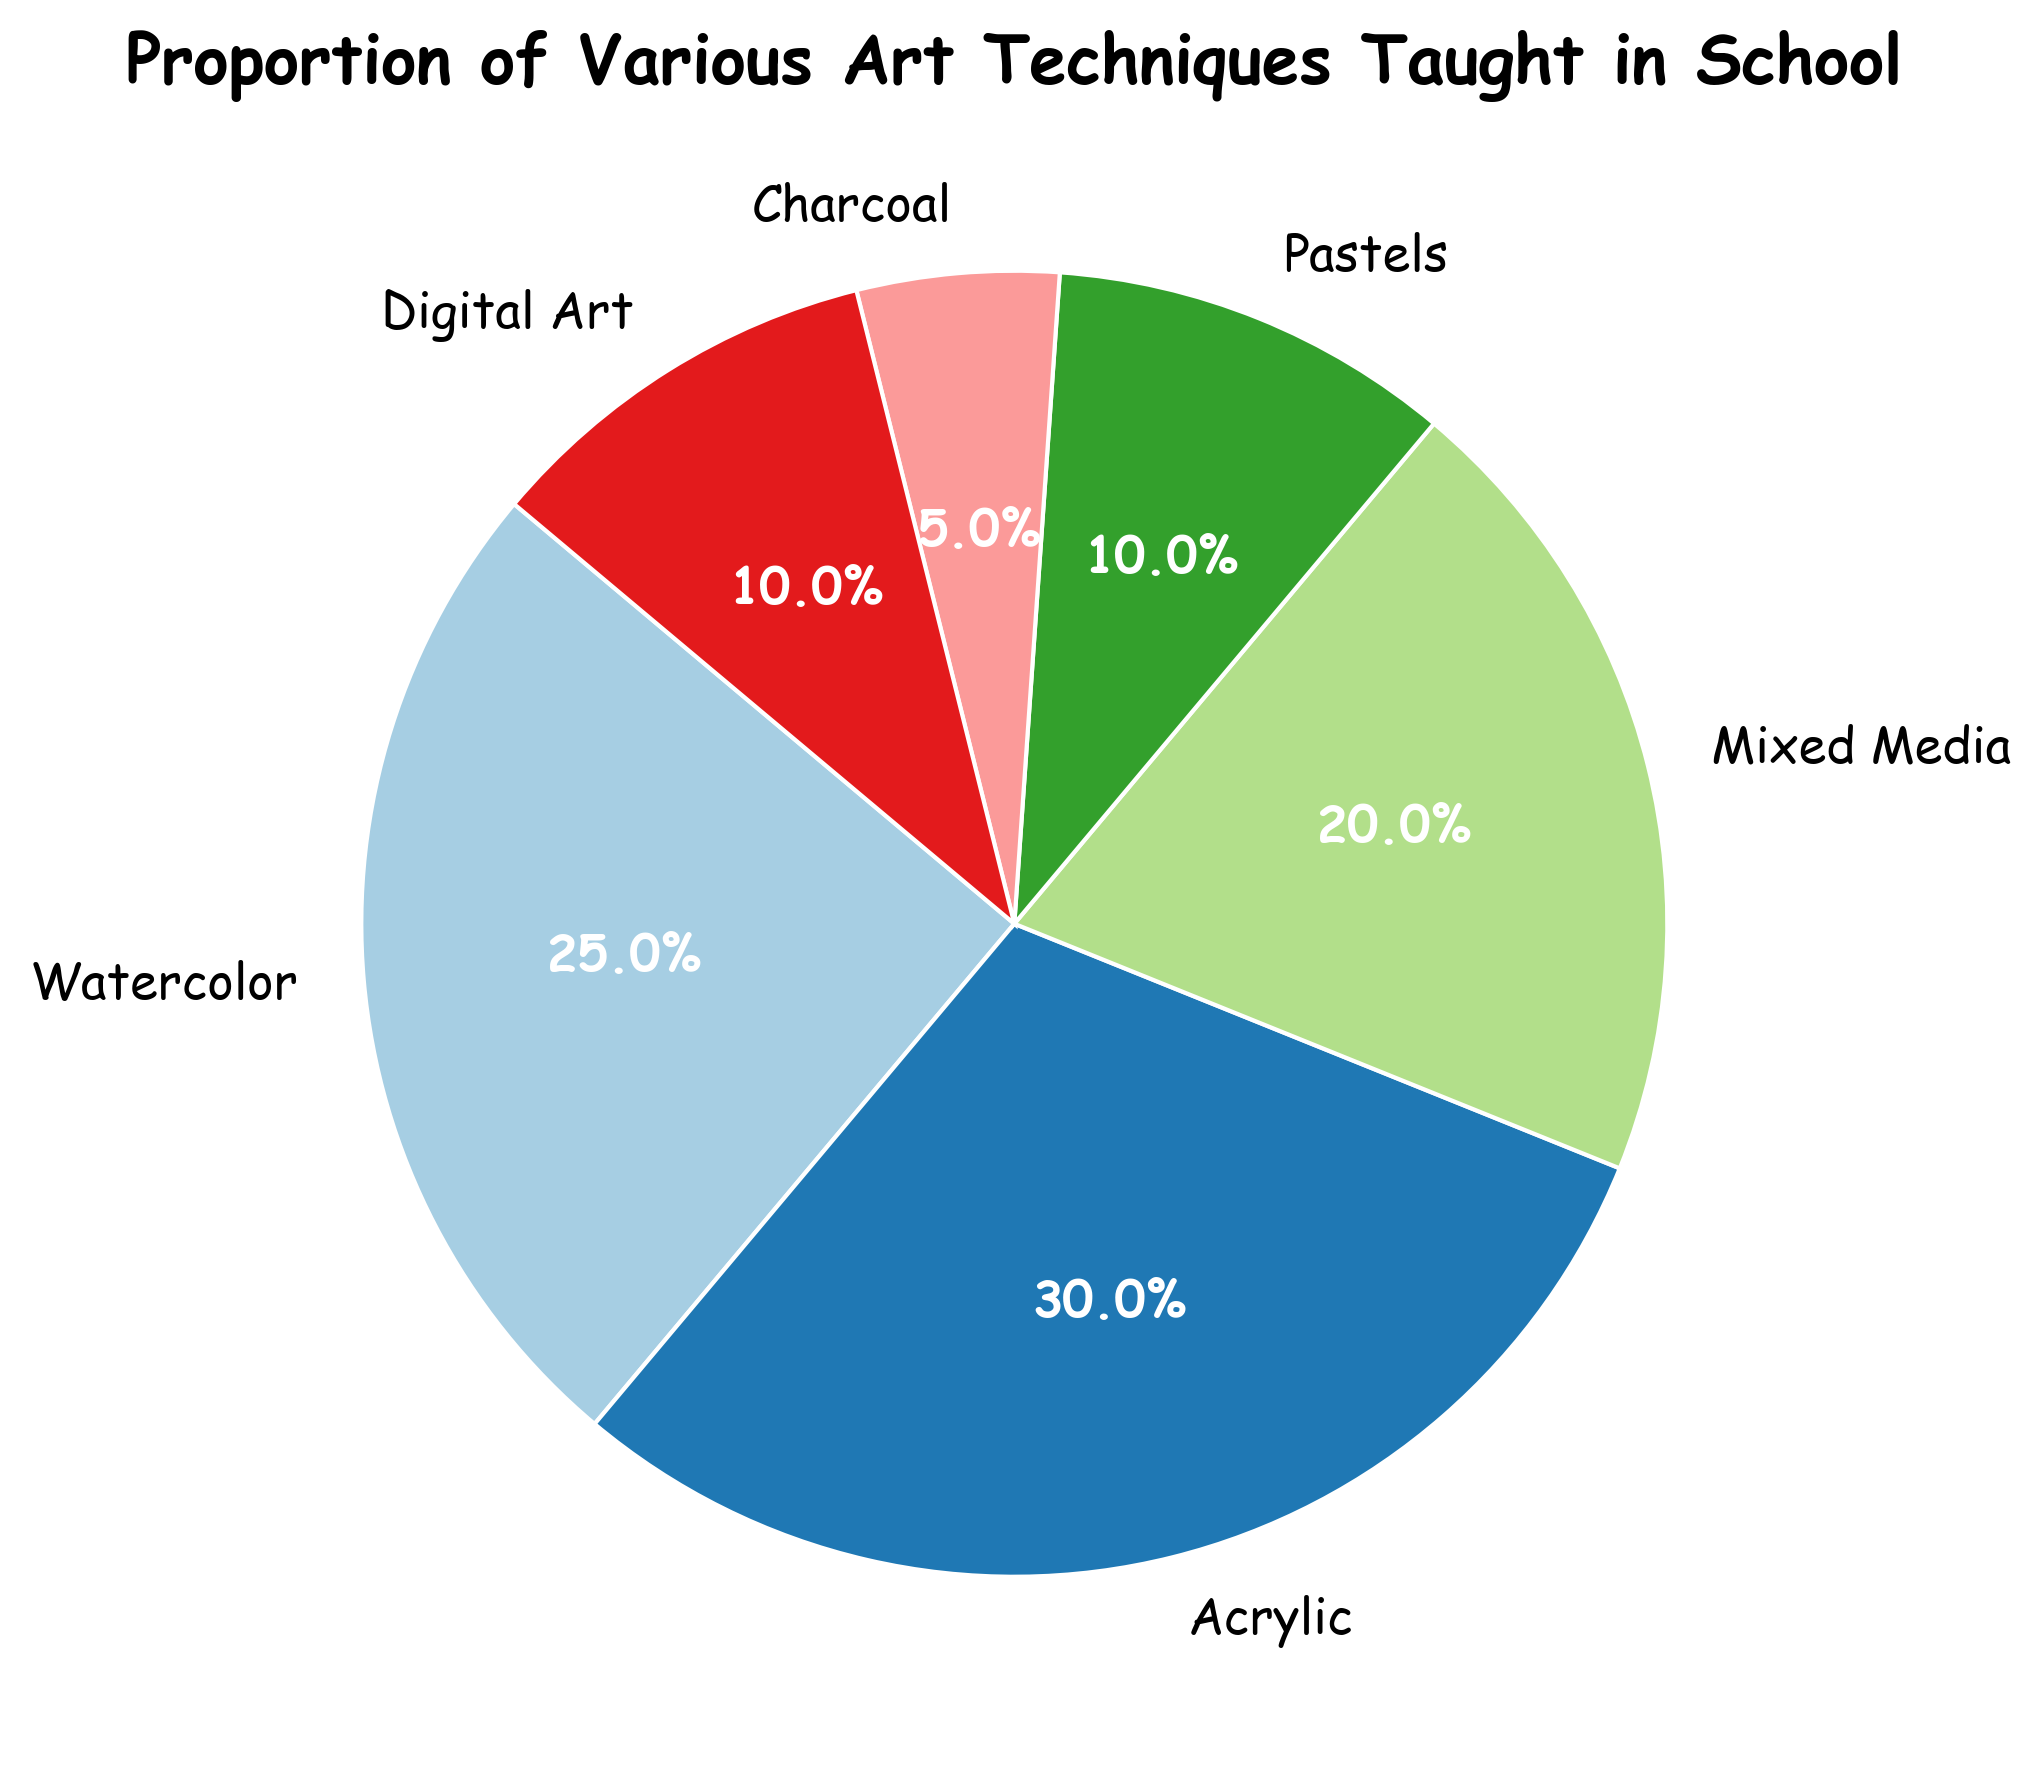Which art technique takes up the largest proportion in the school curriculum? By looking at the pie chart, we can see that Acrylic takes up the largest segment of the chart. The segment labeled Acrylic has the largest percentage shown.
Answer: Acrylic Which two art techniques combined have the same proportion as Acrylic? According to the chart, Acrylic is 30%. The segments for Watercolor and Mixed Media are 25% and 20% respectively. Adding these two: 25% + 20% = 45%, which is greater. But for the next two largest techniques — Watercolor (25%) and Pastels (10%) — we get 25% + 10% = 35%, which is closer but still greater. However, Mixed Media (20%) and Pastels (10%) yield 20% + 10% = 30%, which is exactly equal to Acrylic.
Answer: Mixed Media and Pastels By what percentage is Acrylic larger than Digital Art? Acrylic is 30% and Digital Art is 10%. Subtract the proportion of Digital Art from Acrylic: 30% - 10% = 20%. Therefore, Acrylic is 20% larger than Digital Art.
Answer: 20% Which art technique constitutes the smallest proportion of the curriculum? The smallest segment in the pie chart is labeled as Charcoal. The percentage for Charcoal is the lowest among all techniques shown.
Answer: Charcoal What is the total proportion of traditional art techniques (Watercolor, Acrylic, Pastels, Charcoal) in the curriculum? Adding the proportions for Watercolor (25%), Acrylic (30%), Pastels (10%), and Charcoal (5%): 25% + 30% + 10% + 5% = 70%. Therefore, the total proportion of traditional art techniques is 70%.
Answer: 70% Is the proportion of Watercolor and Digital Art together greater or less than Acrylic alone? Watercolor is 25% and Digital Art is 10%. Adding these two gives: 25% + 10% = 35%. Acrylic alone is 30%. Therefore, the combined proportion of Watercolor and Digital Art is greater than Acrylic alone.
Answer: Greater How much smaller is the proportion of Charcoal compared to Mixed Media? The proportion for Charcoal is 5% and for Mixed Media is 20%. Subtract the proportion of Charcoal from Mixed Media: 20% - 5% = 15%. Therefore, Charcoal is 15% smaller than Mixed Media.
Answer: 15% Which three art techniques together make up over half of the curriculum? The three largest segments are Acrylic (30%), Watercolor (25%), and Mixed Media (20%). Adding these together: 30% + 25% + 20% = 75%. Thus, Acrylic, Watercolor, and Mixed Media together make up over half of the curriculum.
Answer: Acrylic, Watercolor, and Mixed Media 